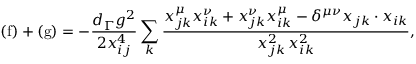Convert formula to latex. <formula><loc_0><loc_0><loc_500><loc_500>( f ) + ( g ) = - \frac { d _ { \Gamma } g ^ { 2 } } { 2 x _ { i j } ^ { 4 } } \sum _ { k } \frac { x _ { j k } ^ { \mu } x _ { i k } ^ { \nu } + x _ { j k } ^ { \nu } x _ { i k } ^ { \mu } - \delta ^ { \mu \nu } x _ { j k } \cdot x _ { i k } } { x _ { j k } ^ { 2 } \, x _ { i k } ^ { 2 } } ,</formula> 